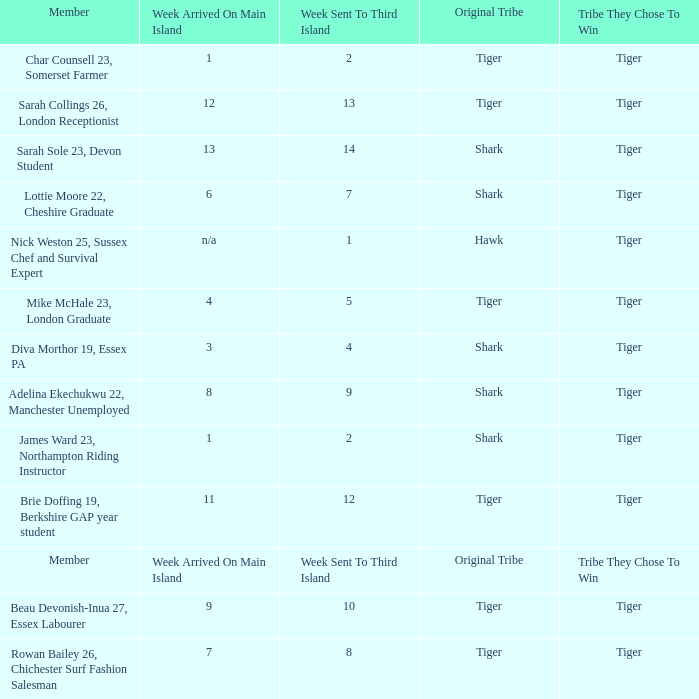How many members arrived on the main island in week 4? 1.0. 